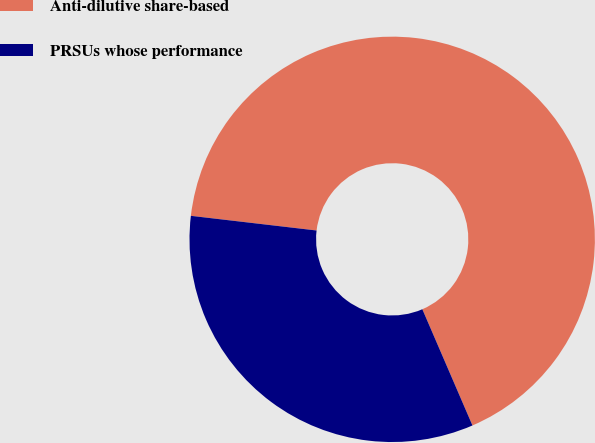Convert chart. <chart><loc_0><loc_0><loc_500><loc_500><pie_chart><fcel>Anti-dilutive share-based<fcel>PRSUs whose performance<nl><fcel>66.67%<fcel>33.33%<nl></chart> 